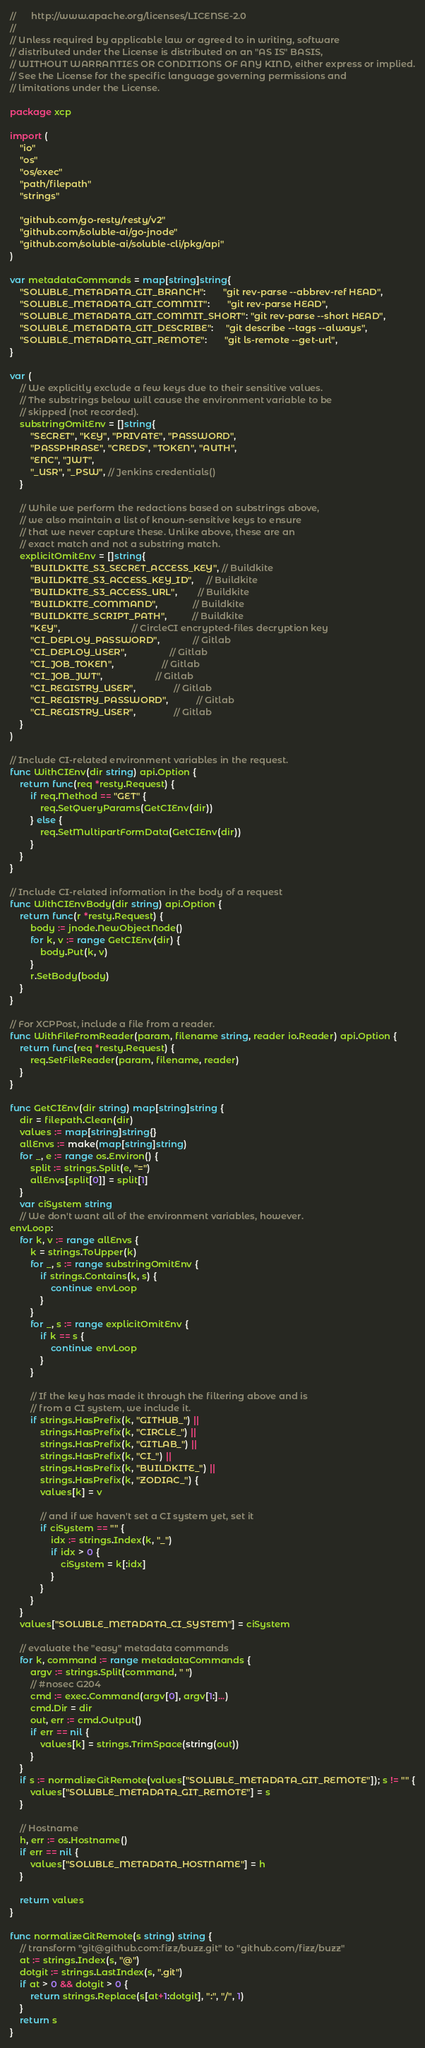<code> <loc_0><loc_0><loc_500><loc_500><_Go_>//      http://www.apache.org/licenses/LICENSE-2.0
//
// Unless required by applicable law or agreed to in writing, software
// distributed under the License is distributed on an "AS IS" BASIS,
// WITHOUT WARRANTIES OR CONDITIONS OF ANY KIND, either express or implied.
// See the License for the specific language governing permissions and
// limitations under the License.

package xcp

import (
	"io"
	"os"
	"os/exec"
	"path/filepath"
	"strings"

	"github.com/go-resty/resty/v2"
	"github.com/soluble-ai/go-jnode"
	"github.com/soluble-ai/soluble-cli/pkg/api"
)

var metadataCommands = map[string]string{
	"SOLUBLE_METADATA_GIT_BRANCH":       "git rev-parse --abbrev-ref HEAD",
	"SOLUBLE_METADATA_GIT_COMMIT":       "git rev-parse HEAD",
	"SOLUBLE_METADATA_GIT_COMMIT_SHORT": "git rev-parse --short HEAD",
	"SOLUBLE_METADATA_GIT_DESCRIBE":     "git describe --tags --always",
	"SOLUBLE_METADATA_GIT_REMOTE":       "git ls-remote --get-url",
}

var (
	// We explicitly exclude a few keys due to their sensitive values.
	// The substrings below will cause the environment variable to be
	// skipped (not recorded).
	substringOmitEnv = []string{
		"SECRET", "KEY", "PRIVATE", "PASSWORD",
		"PASSPHRASE", "CREDS", "TOKEN", "AUTH",
		"ENC", "JWT",
		"_USR", "_PSW", // Jenkins credentials()
	}

	// While we perform the redactions based on substrings above,
	// we also maintain a list of known-sensitive keys to ensure
	// that we never capture these. Unlike above, these are an
	// exact match and not a substring match.
	explicitOmitEnv = []string{
		"BUILDKITE_S3_SECRET_ACCESS_KEY", // Buildkite
		"BUILDKITE_S3_ACCESS_KEY_ID",     // Buildkite
		"BUILDKITE_S3_ACCESS_URL",        // Buildkite
		"BUILDKITE_COMMAND",              // Buildkite
		"BUILDKITE_SCRIPT_PATH",          // Buildkite
		"KEY",                            // CircleCI encrypted-files decryption key
		"CI_DEPLOY_PASSWORD",             // Gitlab
		"CI_DEPLOY_USER",                 // Gitlab
		"CI_JOB_TOKEN",                   // Gitlab
		"CI_JOB_JWT",                     // Gitlab
		"CI_REGISTRY_USER",               // Gitlab
		"CI_REGISTRY_PASSWORD",           // Gitlab
		"CI_REGISTRY_USER",               // Gitlab
	}
)

// Include CI-related environment variables in the request.
func WithCIEnv(dir string) api.Option {
	return func(req *resty.Request) {
		if req.Method == "GET" {
			req.SetQueryParams(GetCIEnv(dir))
		} else {
			req.SetMultipartFormData(GetCIEnv(dir))
		}
	}
}

// Include CI-related information in the body of a request
func WithCIEnvBody(dir string) api.Option {
	return func(r *resty.Request) {
		body := jnode.NewObjectNode()
		for k, v := range GetCIEnv(dir) {
			body.Put(k, v)
		}
		r.SetBody(body)
	}
}

// For XCPPost, include a file from a reader.
func WithFileFromReader(param, filename string, reader io.Reader) api.Option {
	return func(req *resty.Request) {
		req.SetFileReader(param, filename, reader)
	}
}

func GetCIEnv(dir string) map[string]string {
	dir = filepath.Clean(dir)
	values := map[string]string{}
	allEnvs := make(map[string]string)
	for _, e := range os.Environ() {
		split := strings.Split(e, "=")
		allEnvs[split[0]] = split[1]
	}
	var ciSystem string
	// We don't want all of the environment variables, however.
envLoop:
	for k, v := range allEnvs {
		k = strings.ToUpper(k)
		for _, s := range substringOmitEnv {
			if strings.Contains(k, s) {
				continue envLoop
			}
		}
		for _, s := range explicitOmitEnv {
			if k == s {
				continue envLoop
			}
		}

		// If the key has made it through the filtering above and is
		// from a CI system, we include it.
		if strings.HasPrefix(k, "GITHUB_") ||
			strings.HasPrefix(k, "CIRCLE_") ||
			strings.HasPrefix(k, "GITLAB_") ||
			strings.HasPrefix(k, "CI_") ||
			strings.HasPrefix(k, "BUILDKITE_") ||
			strings.HasPrefix(k, "ZODIAC_") {
			values[k] = v

			// and if we haven't set a CI system yet, set it
			if ciSystem == "" {
				idx := strings.Index(k, "_")
				if idx > 0 {
					ciSystem = k[:idx]
				}
			}
		}
	}
	values["SOLUBLE_METADATA_CI_SYSTEM"] = ciSystem

	// evaluate the "easy" metadata commands
	for k, command := range metadataCommands {
		argv := strings.Split(command, " ")
		// #nosec G204
		cmd := exec.Command(argv[0], argv[1:]...)
		cmd.Dir = dir
		out, err := cmd.Output()
		if err == nil {
			values[k] = strings.TrimSpace(string(out))
		}
	}
	if s := normalizeGitRemote(values["SOLUBLE_METADATA_GIT_REMOTE"]); s != "" {
		values["SOLUBLE_METADATA_GIT_REMOTE"] = s
	}

	// Hostname
	h, err := os.Hostname()
	if err == nil {
		values["SOLUBLE_METADATA_HOSTNAME"] = h
	}

	return values
}

func normalizeGitRemote(s string) string {
	// transform "git@github.com:fizz/buzz.git" to "github.com/fizz/buzz"
	at := strings.Index(s, "@")
	dotgit := strings.LastIndex(s, ".git")
	if at > 0 && dotgit > 0 {
		return strings.Replace(s[at+1:dotgit], ":", "/", 1)
	}
	return s
}
</code> 